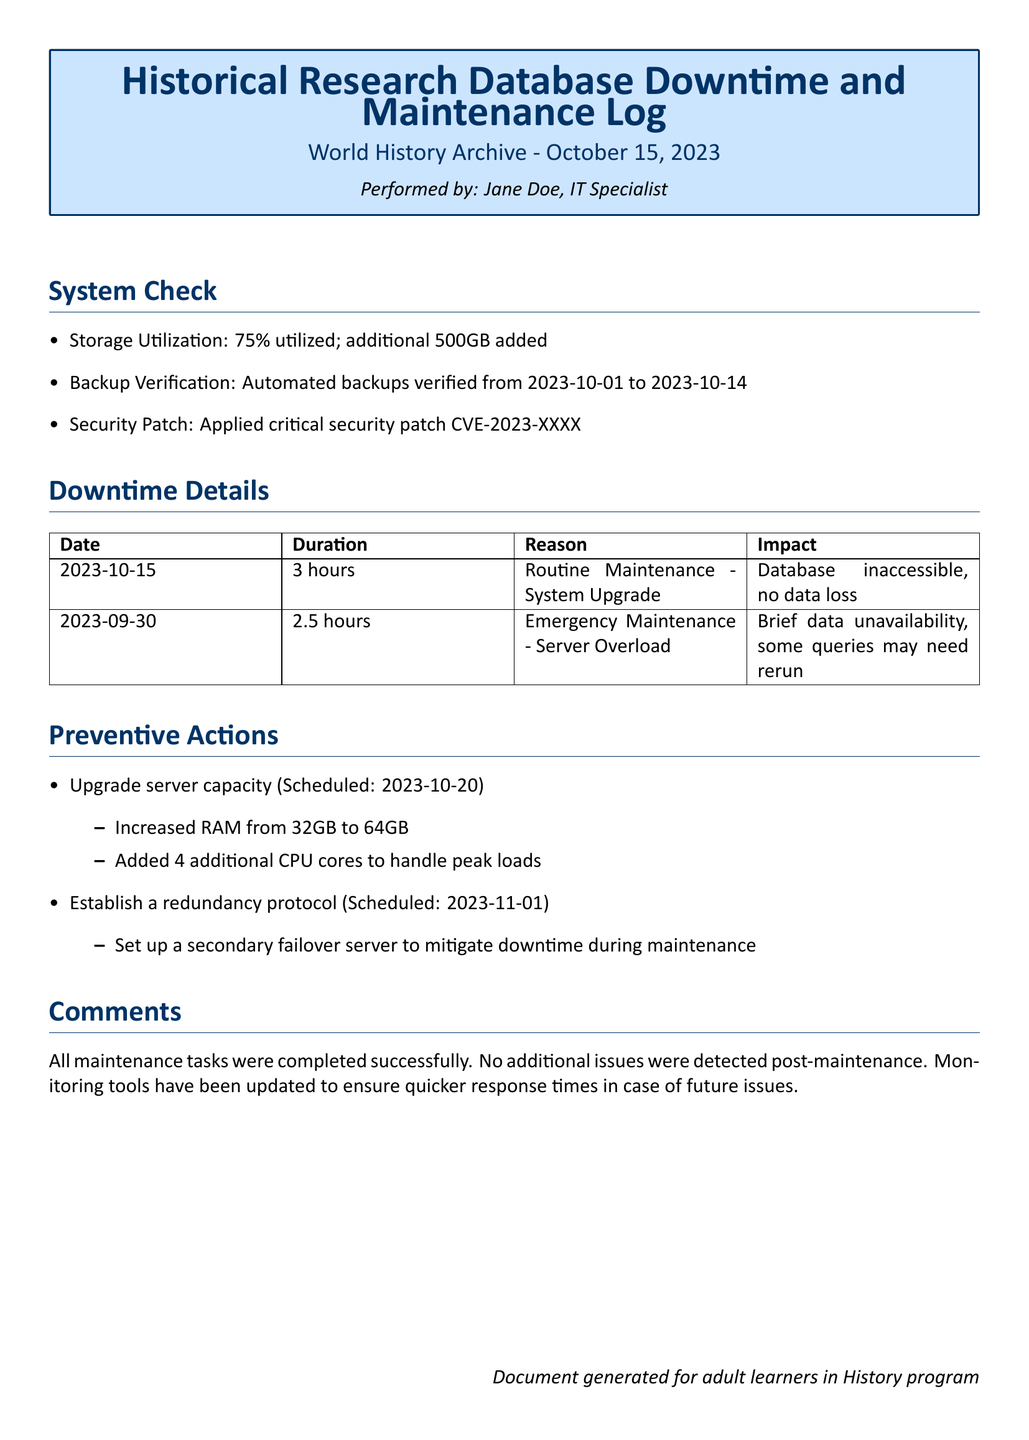what is the date of the log? The log is dated October 15, 2023, as mentioned in the document header.
Answer: October 15, 2023 who performed the maintenance? The maintenance was performed by Jane Doe, as stated in the document.
Answer: Jane Doe how long was the downtime on 2023-10-15? The document specifies that the downtime on this date lasted for 3 hours.
Answer: 3 hours what was the reason for the downtime on 2023-09-30? The reason provided for the downtime on this date was Emergency Maintenance due to Server Overload.
Answer: Emergency Maintenance - Server Overload what is the new RAM capacity being upgraded to? The RAM capacity is being increased from 32GB to 64GB, as detailed under preventive actions.
Answer: 64GB what action is scheduled for 2023-11-01? The action scheduled for this date is to establish a redundancy protocol.
Answer: Establish a redundancy protocol how many additional CPU cores are being added? The document mentions the addition of 4 additional CPU cores as part of the server capacity upgrade.
Answer: 4 what is the storage utilization percentage before the maintenance? The storage utilization before maintenance was reported as 75%.
Answer: 75% was there any data loss during the maintenance on 2023-10-15? The document confirms that there was no data loss during the maintenance on this date.
Answer: No data loss 